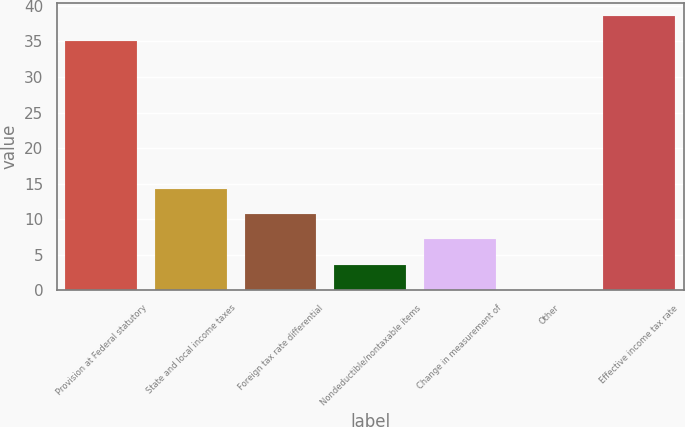Convert chart. <chart><loc_0><loc_0><loc_500><loc_500><bar_chart><fcel>Provision at Federal statutory<fcel>State and local income taxes<fcel>Foreign tax rate differential<fcel>Nondeductible/nontaxable items<fcel>Change in measurement of<fcel>Other<fcel>Effective income tax rate<nl><fcel>35<fcel>14.18<fcel>10.66<fcel>3.62<fcel>7.14<fcel>0.1<fcel>38.52<nl></chart> 